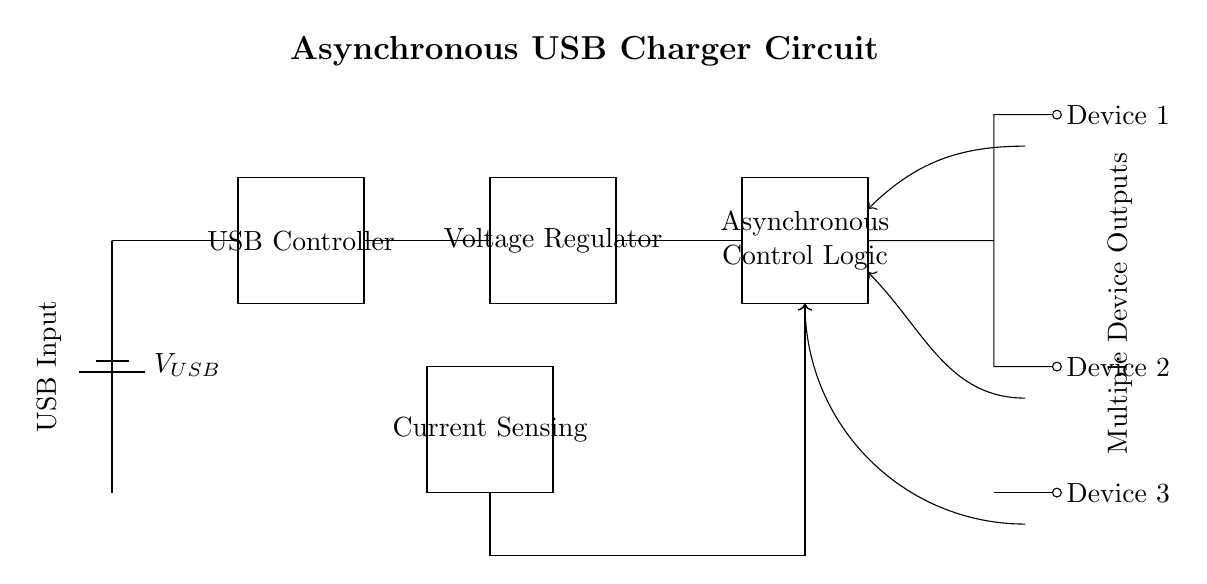What is the voltage input for the USB charger? The voltage is represented by V_USB in the circuit, which is typically 5 volts for USB devices.
Answer: 5 volts What is the purpose of the voltage regulator in this circuit? The voltage regulator is used to maintain a steady output voltage, ensuring that the connected devices receive the correct voltage.
Answer: To maintain steady output voltage How many devices can this charger output connect? The circuit diagram shows three separate output connections to devices indicating that it can charge three devices simultaneously.
Answer: Three devices What is the function of the current sensing component? The current sensing component monitors the current flowing through the circuit to provide feedback for the asynchronous control logic regarding power distribution.
Answer: Monitor current flow What role does the asynchronous control logic play in this circuit? The asynchronous control logic manages the output distribution to the connected devices based on their requirements, ensuring optimal charging without interference.
Answer: Manage output distribution What indicates that this charger circuit is asynchronous? The term "Asynchronous" in the control logic block indicates that the circuit can manage multiple devices independently rather than in a synchronized manner.
Answer: Asynchronous control logic 